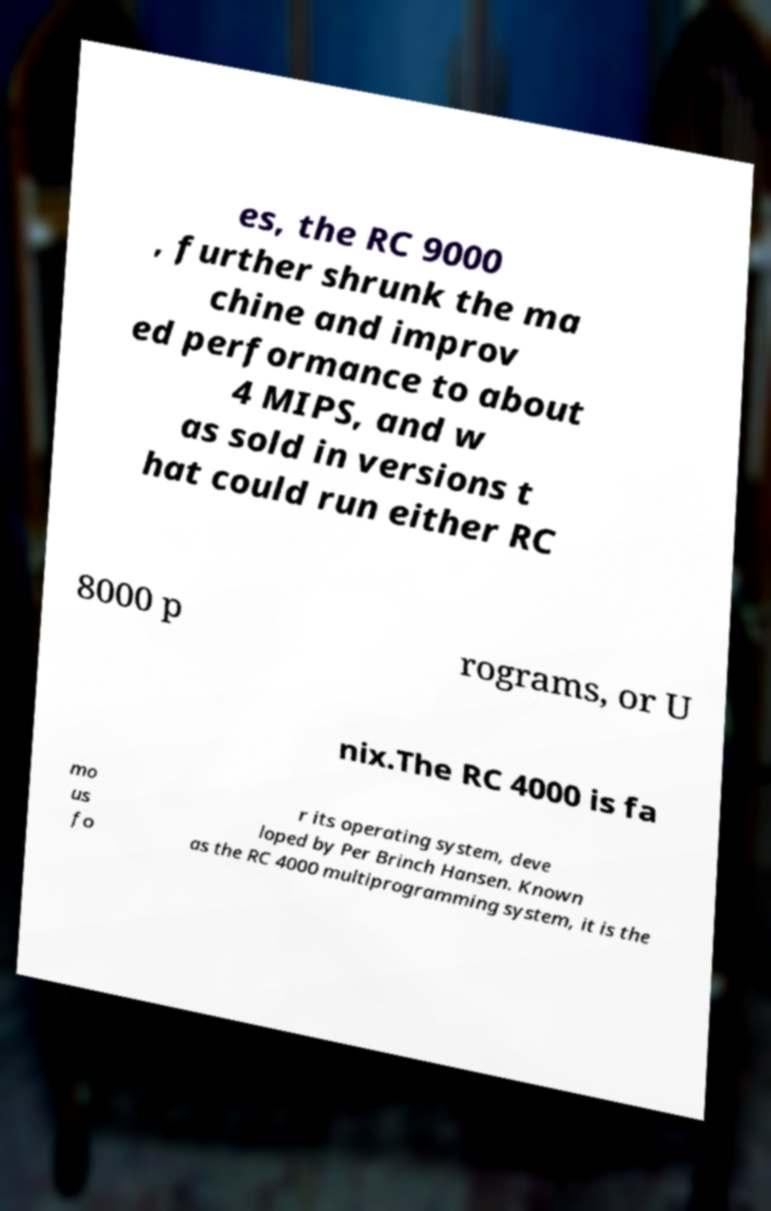I need the written content from this picture converted into text. Can you do that? es, the RC 9000 , further shrunk the ma chine and improv ed performance to about 4 MIPS, and w as sold in versions t hat could run either RC 8000 p rograms, or U nix.The RC 4000 is fa mo us fo r its operating system, deve loped by Per Brinch Hansen. Known as the RC 4000 multiprogramming system, it is the 